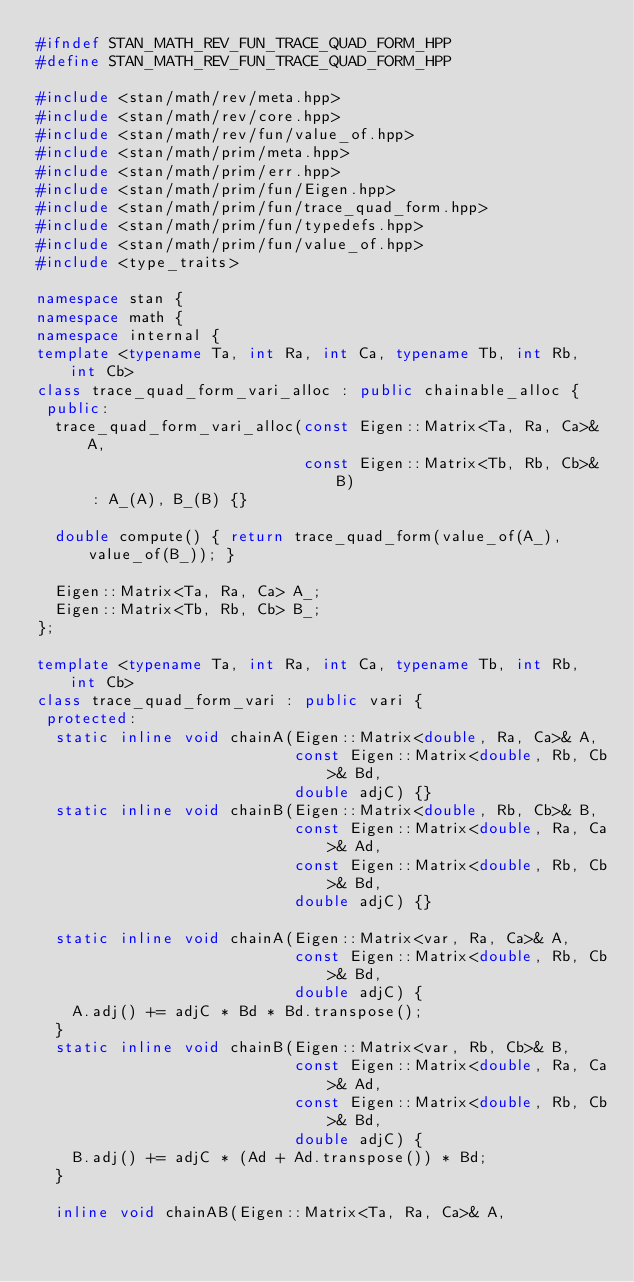<code> <loc_0><loc_0><loc_500><loc_500><_C++_>#ifndef STAN_MATH_REV_FUN_TRACE_QUAD_FORM_HPP
#define STAN_MATH_REV_FUN_TRACE_QUAD_FORM_HPP

#include <stan/math/rev/meta.hpp>
#include <stan/math/rev/core.hpp>
#include <stan/math/rev/fun/value_of.hpp>
#include <stan/math/prim/meta.hpp>
#include <stan/math/prim/err.hpp>
#include <stan/math/prim/fun/Eigen.hpp>
#include <stan/math/prim/fun/trace_quad_form.hpp>
#include <stan/math/prim/fun/typedefs.hpp>
#include <stan/math/prim/fun/value_of.hpp>
#include <type_traits>

namespace stan {
namespace math {
namespace internal {
template <typename Ta, int Ra, int Ca, typename Tb, int Rb, int Cb>
class trace_quad_form_vari_alloc : public chainable_alloc {
 public:
  trace_quad_form_vari_alloc(const Eigen::Matrix<Ta, Ra, Ca>& A,
                             const Eigen::Matrix<Tb, Rb, Cb>& B)
      : A_(A), B_(B) {}

  double compute() { return trace_quad_form(value_of(A_), value_of(B_)); }

  Eigen::Matrix<Ta, Ra, Ca> A_;
  Eigen::Matrix<Tb, Rb, Cb> B_;
};

template <typename Ta, int Ra, int Ca, typename Tb, int Rb, int Cb>
class trace_quad_form_vari : public vari {
 protected:
  static inline void chainA(Eigen::Matrix<double, Ra, Ca>& A,
                            const Eigen::Matrix<double, Rb, Cb>& Bd,
                            double adjC) {}
  static inline void chainB(Eigen::Matrix<double, Rb, Cb>& B,
                            const Eigen::Matrix<double, Ra, Ca>& Ad,
                            const Eigen::Matrix<double, Rb, Cb>& Bd,
                            double adjC) {}

  static inline void chainA(Eigen::Matrix<var, Ra, Ca>& A,
                            const Eigen::Matrix<double, Rb, Cb>& Bd,
                            double adjC) {
    A.adj() += adjC * Bd * Bd.transpose();
  }
  static inline void chainB(Eigen::Matrix<var, Rb, Cb>& B,
                            const Eigen::Matrix<double, Ra, Ca>& Ad,
                            const Eigen::Matrix<double, Rb, Cb>& Bd,
                            double adjC) {
    B.adj() += adjC * (Ad + Ad.transpose()) * Bd;
  }

  inline void chainAB(Eigen::Matrix<Ta, Ra, Ca>& A,</code> 